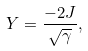<formula> <loc_0><loc_0><loc_500><loc_500>Y = \frac { - 2 J } { \sqrt { \gamma } } ,</formula> 